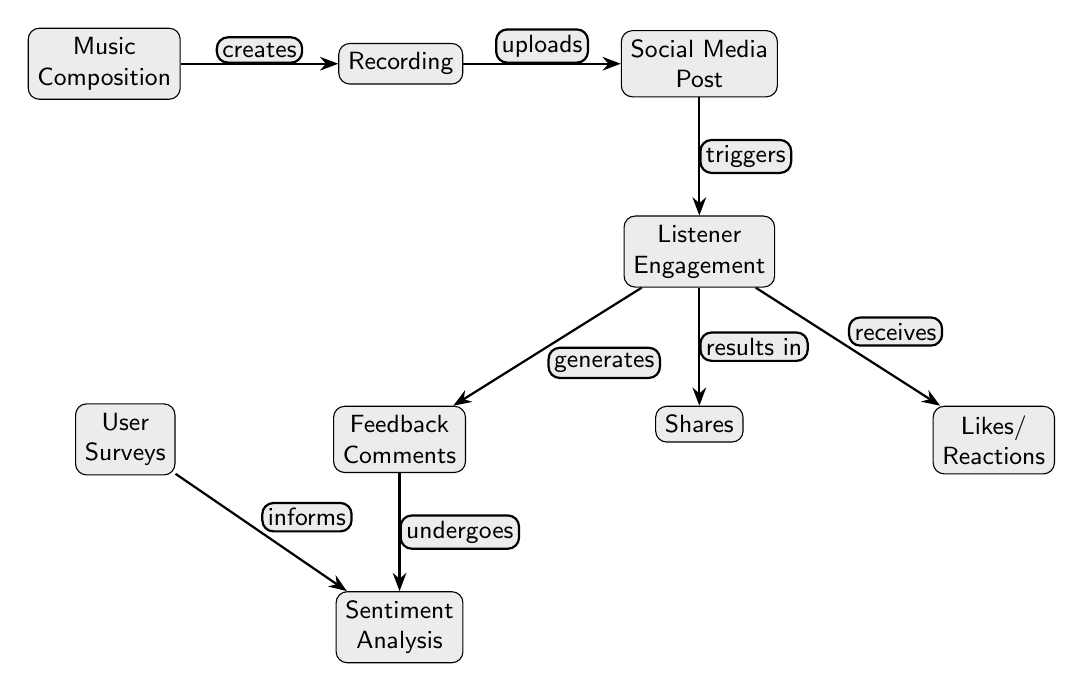What is the first step in the flow of this diagram? The first step is the creation of music through composition, which is the starting node in the diagram.
Answer: Music Composition How many main nodes are there in the diagram? By counting all distinct nodes in the diagram, we find there are a total of 8 main nodes.
Answer: 8 What does the music composition create? The music composition leads to recording, which is the direct successor node following it in the flow.
Answer: Recording What action triggers listener engagement? The action that triggers listener engagement is the posting on social media, which is the connecting edge from the social media post node to the listener engagement node.
Answer: Social Media Post What is analyzed based on feedback comments? Sentiment analysis is performed based on feedback comments, indicated by the edge connecting these two nodes.
Answer: Sentiment Analysis What relationship exists between user surveys and sentiment analysis? User surveys inform sentiment analysis, demonstrating a directional flow of information from user surveys to sentiment analysis.
Answer: Informs Which node results in shares? Shares are generated directly from listener engagement, according to the direction of the arrows indicating the relationship.
Answer: Listener Engagement How many types of engagements are listed after listener engagement? There are three types of engagements listed: feedback comments, shares, and likes/reactions, which can be counted from the nodes below listener engagement.
Answer: 3 What is the last node in the flow of the diagram? The last node in the flow is sentiment analysis, which receives inputs from feedback comments and user surveys.
Answer: Sentiment Analysis 